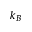Convert formula to latex. <formula><loc_0><loc_0><loc_500><loc_500>k _ { B }</formula> 